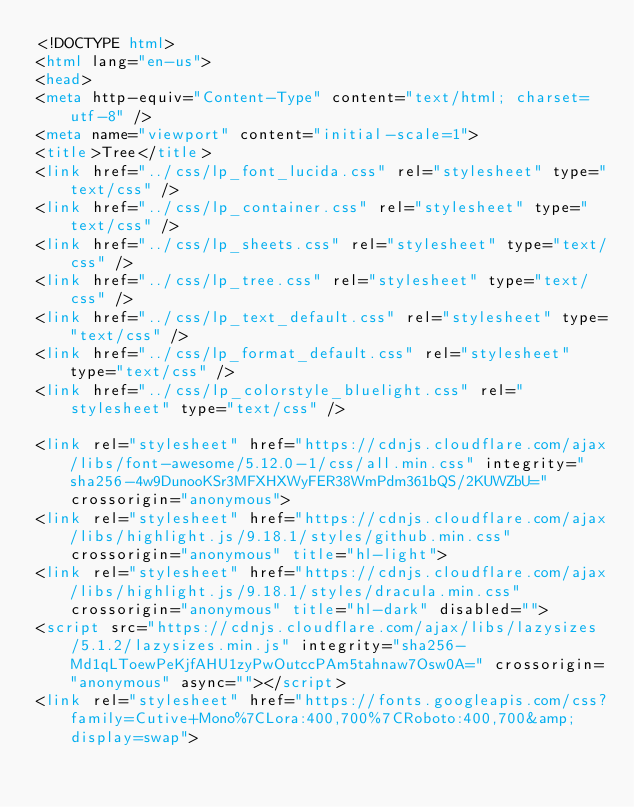Convert code to text. <code><loc_0><loc_0><loc_500><loc_500><_HTML_><!DOCTYPE html>
<html lang="en-us">
<head>
<meta http-equiv="Content-Type" content="text/html; charset=utf-8" />
<meta name="viewport" content="initial-scale=1">
<title>Tree</title>
<link href="../css/lp_font_lucida.css" rel="stylesheet" type="text/css" />
<link href="../css/lp_container.css" rel="stylesheet" type="text/css" />
<link href="../css/lp_sheets.css" rel="stylesheet" type="text/css" />
<link href="../css/lp_tree.css" rel="stylesheet" type="text/css" />
<link href="../css/lp_text_default.css" rel="stylesheet" type="text/css" />
<link href="../css/lp_format_default.css" rel="stylesheet" type="text/css" />
<link href="../css/lp_colorstyle_bluelight.css" rel="stylesheet" type="text/css" />

<link rel="stylesheet" href="https://cdnjs.cloudflare.com/ajax/libs/font-awesome/5.12.0-1/css/all.min.css" integrity="sha256-4w9DunooKSr3MFXHXWyFER38WmPdm361bQS/2KUWZbU=" crossorigin="anonymous">
<link rel="stylesheet" href="https://cdnjs.cloudflare.com/ajax/libs/highlight.js/9.18.1/styles/github.min.css" crossorigin="anonymous" title="hl-light">
<link rel="stylesheet" href="https://cdnjs.cloudflare.com/ajax/libs/highlight.js/9.18.1/styles/dracula.min.css" crossorigin="anonymous" title="hl-dark" disabled="">
<script src="https://cdnjs.cloudflare.com/ajax/libs/lazysizes/5.1.2/lazysizes.min.js" integrity="sha256-Md1qLToewPeKjfAHU1zyPwOutccPAm5tahnaw7Osw0A=" crossorigin="anonymous" async=""></script>
<link rel="stylesheet" href="https://fonts.googleapis.com/css?family=Cutive+Mono%7CLora:400,700%7CRoboto:400,700&amp;display=swap"></code> 